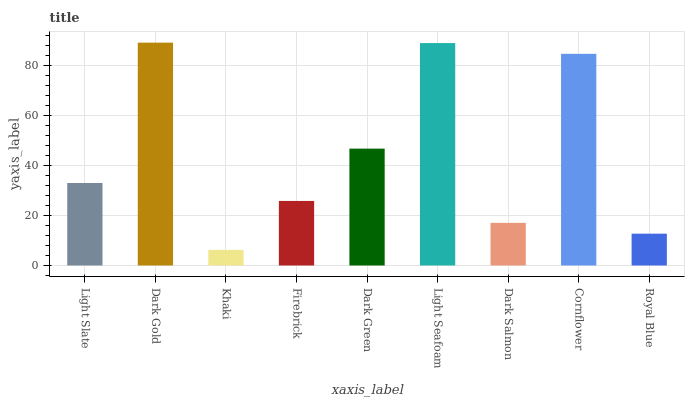Is Khaki the minimum?
Answer yes or no. Yes. Is Dark Gold the maximum?
Answer yes or no. Yes. Is Dark Gold the minimum?
Answer yes or no. No. Is Khaki the maximum?
Answer yes or no. No. Is Dark Gold greater than Khaki?
Answer yes or no. Yes. Is Khaki less than Dark Gold?
Answer yes or no. Yes. Is Khaki greater than Dark Gold?
Answer yes or no. No. Is Dark Gold less than Khaki?
Answer yes or no. No. Is Light Slate the high median?
Answer yes or no. Yes. Is Light Slate the low median?
Answer yes or no. Yes. Is Dark Green the high median?
Answer yes or no. No. Is Royal Blue the low median?
Answer yes or no. No. 